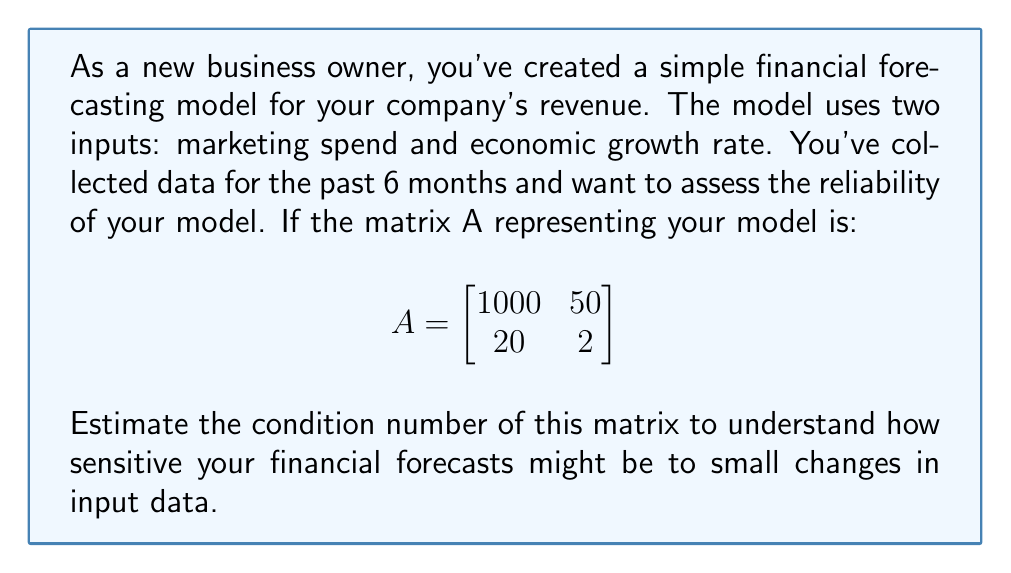Show me your answer to this math problem. To estimate the condition number of the matrix A, we'll follow these steps:

1. The condition number is defined as:
   $$\kappa(A) = \|A\| \cdot \|A^{-1}\|$$
   where $\|A\|$ is the matrix norm.

2. For simplicity, we'll use the 2-norm (spectral norm), which for a square matrix is the largest singular value.

3. To find singular values, we need to calculate eigenvalues of $A^TA$:

   $$A^TA = \begin{bmatrix}
   1000 & 20 \\
   50 & 2
   \end{bmatrix} \begin{bmatrix}
   1000 & 50 \\
   20 & 2
   \end{bmatrix} = \begin{bmatrix}
   1,000,400 & 50,100 \\
   50,100 & 2,504
   \end{bmatrix}$$

4. The characteristic equation is:
   $$(1,000,400 - \lambda)(2,504 - \lambda) - (50,100)^2 = 0$$

5. Solving this equation (which is complex, so we'll estimate):
   $\lambda_1 \approx 1,000,404$ and $\lambda_2 \approx 2,500$

6. The singular values are the square roots of these eigenvalues:
   $\sigma_1 \approx 1000.2$ and $\sigma_2 \approx 50$

7. The largest singular value is $\sigma_1 \approx 1000.2$, so $\|A\| \approx 1000.2$

8. For $A^{-1}$, we can use the property that its singular values are the reciprocals of A's singular values:
   $\|A^{-1}\| \approx \frac{1}{50} = 0.02$

9. Therefore, the condition number is approximately:
   $$\kappa(A) \approx 1000.2 \cdot 0.02 = 20.004$$
Answer: $\kappa(A) \approx 20$ 